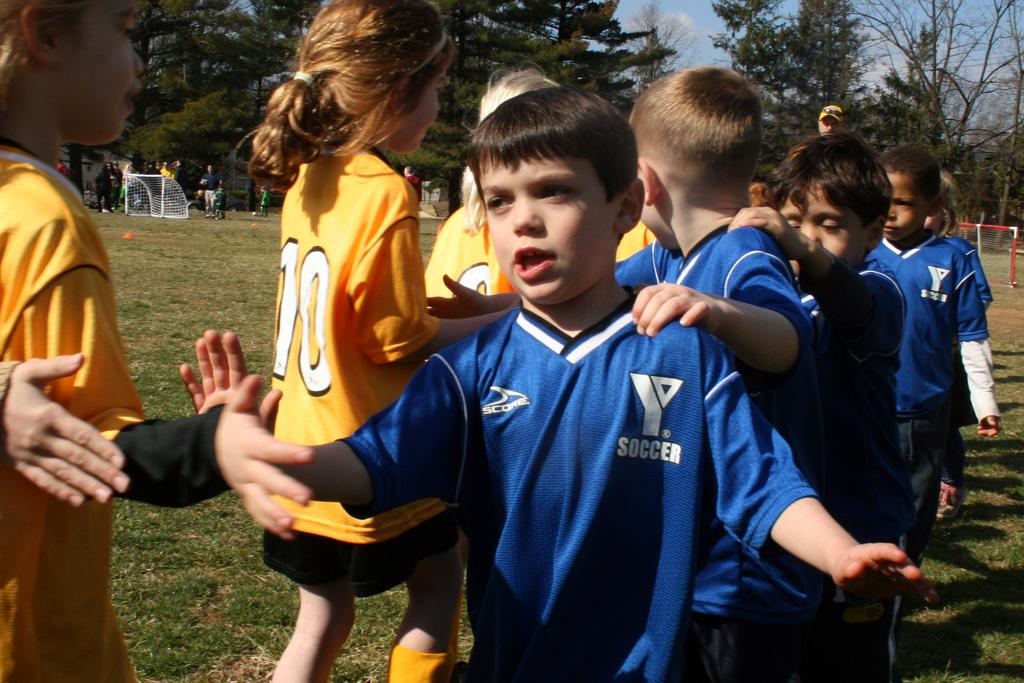<image>
Relay a brief, clear account of the picture shown. The girl has number 10 on the back of her yellow soccer shirt and the boy has SCORE and SOCCER written on his blue shirt with other kids around them. 